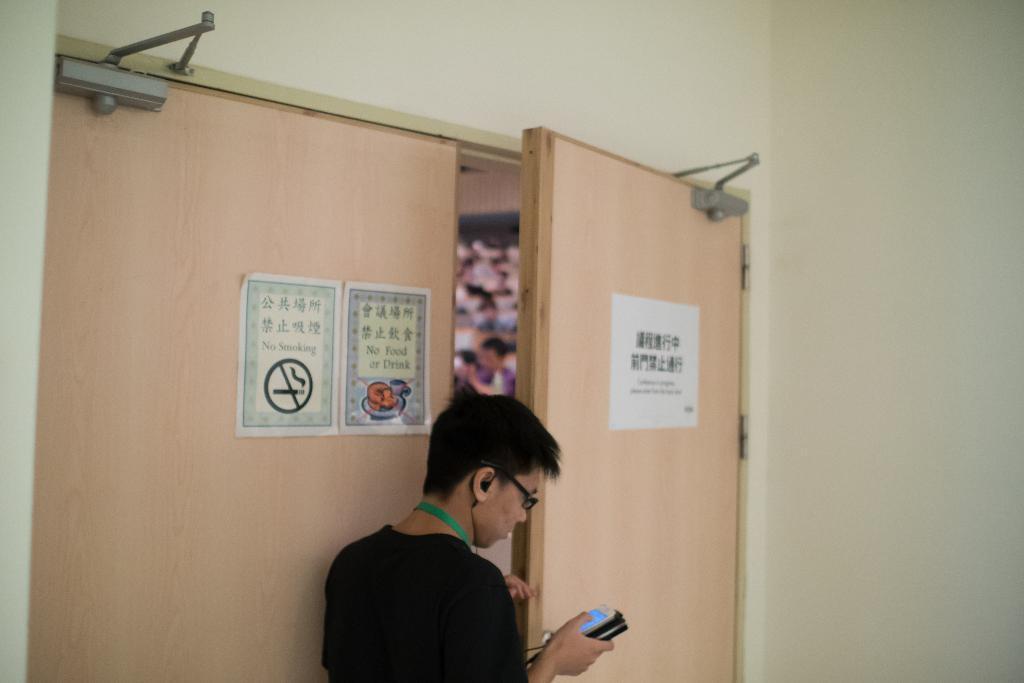How would you summarize this image in a sentence or two? In this image there is a person standing and holding a mobile, in front of him there is a wooden door on which there are a few posters with some text. In the background there is a wall. 